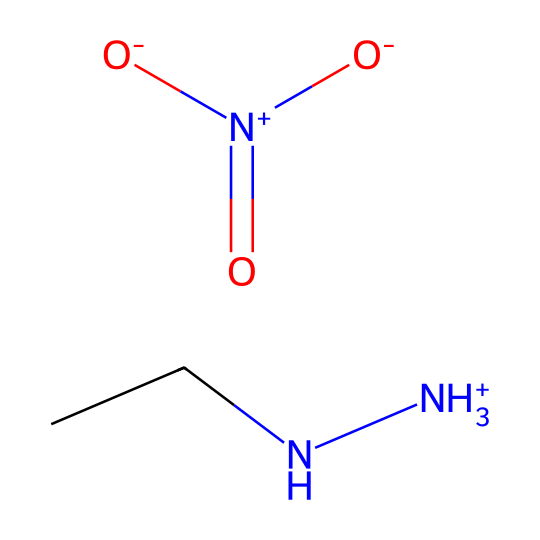What is the total number of nitrogen atoms in this chemical? The SMILES representation shows two distinct nitrogen atoms; one is in the structure CCN (the amine group) and the other is part of the [N+](=O)([O-])[O-] (the cationic part).
Answer: two What type of bonding is primarily present in this chemical? The molecule presents ionic bonding due to the presence of the cation ([N+]) and anions ([O-]), which are characteristic of ionic liquids.
Answer: ionic What functional group is depicted by the [N+](=O)([O-])[O-] part? This part represents a nitrate functional group, indicated by the nitrogen bonded to three oxygen atoms, one with a positive charge and two with negative charges.
Answer: nitrate What is the main characteristic of ionic liquids shown in this compound? The presence of the ionic character in the structure, where the cation is paired with anions, leads to low volatility and high thermal stability typical for ionic liquids.
Answer: low volatility How many oxygen atoms are present in this molecule? Analyzing the SMILES representation, there are three oxygen atoms that are part of the [N+](=O)([O-])[O-] structure.
Answer: three What does the presence of "CCN" suggest about the molecule's behavior? The "CCN" part represents a dialkyl amine, which contributes to the solubility in non-polar solvents and enhances the stability of the ionic liquid phase.
Answer: dialkyl amine 